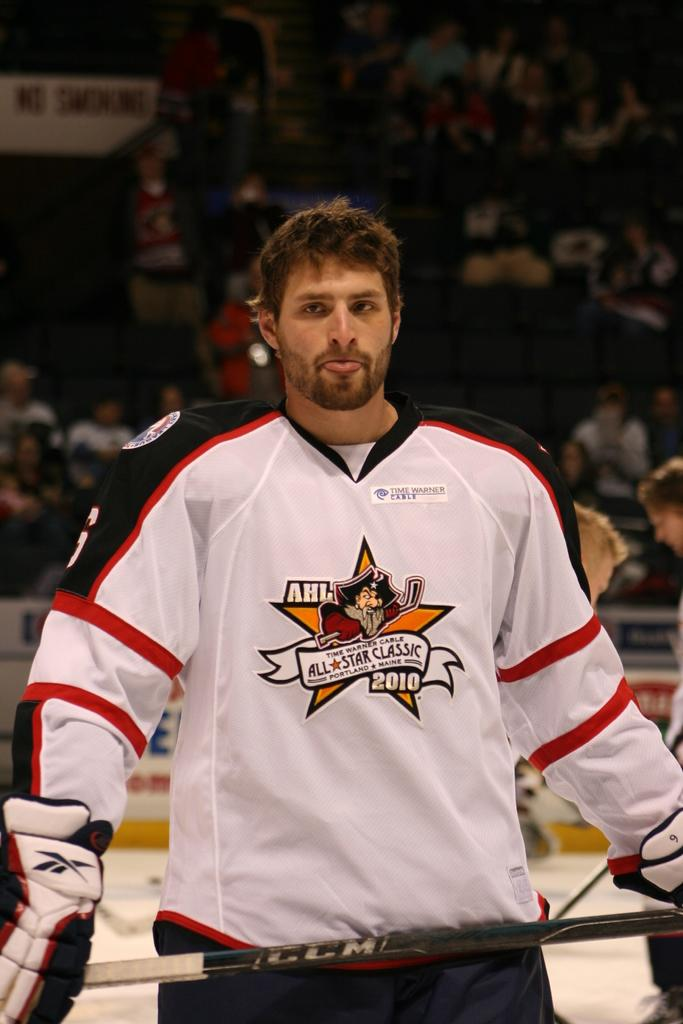<image>
Render a clear and concise summary of the photo. The hockey player wears an AHL jersey for the All Star Classic. 